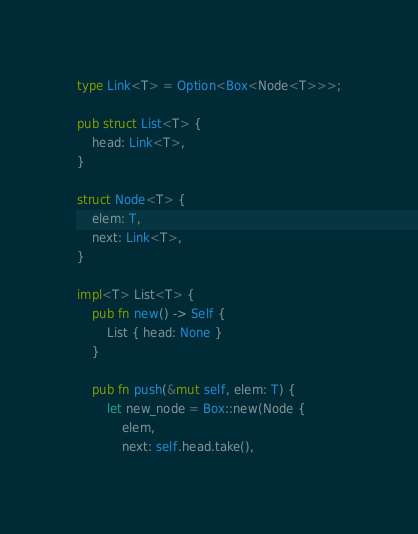Convert code to text. <code><loc_0><loc_0><loc_500><loc_500><_Rust_>type Link<T> = Option<Box<Node<T>>>;

pub struct List<T> {
    head: Link<T>,
}

struct Node<T> {
    elem: T,
    next: Link<T>,
}

impl<T> List<T> {
    pub fn new() -> Self {
        List { head: None }
    }

    pub fn push(&mut self, elem: T) {
        let new_node = Box::new(Node {
            elem,
            next: self.head.take(),</code> 